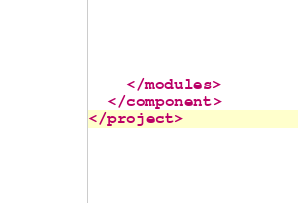Convert code to text. <code><loc_0><loc_0><loc_500><loc_500><_XML_>    </modules>
  </component>
</project></code> 